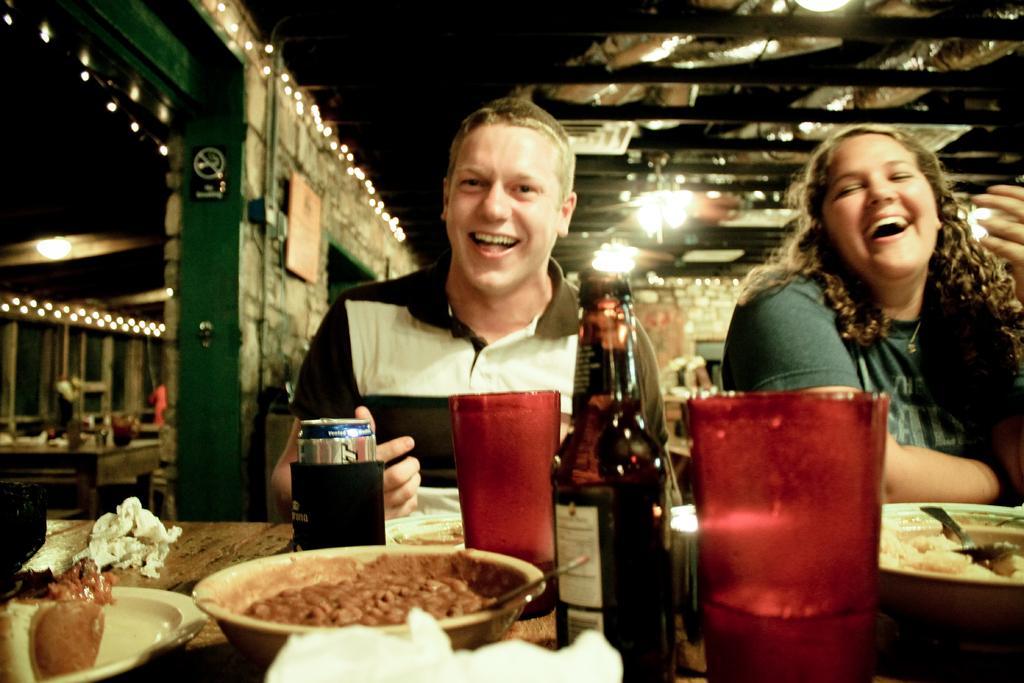Could you give a brief overview of what you see in this image? In this picture we can see a man and a woman smiling and in front of them we can see glasses, bottle, tin, bowls, plate, food items, spoon, tissue papers and these all are placed on a table and in the background we can see the lights, frame on the wall, table and some objects. 